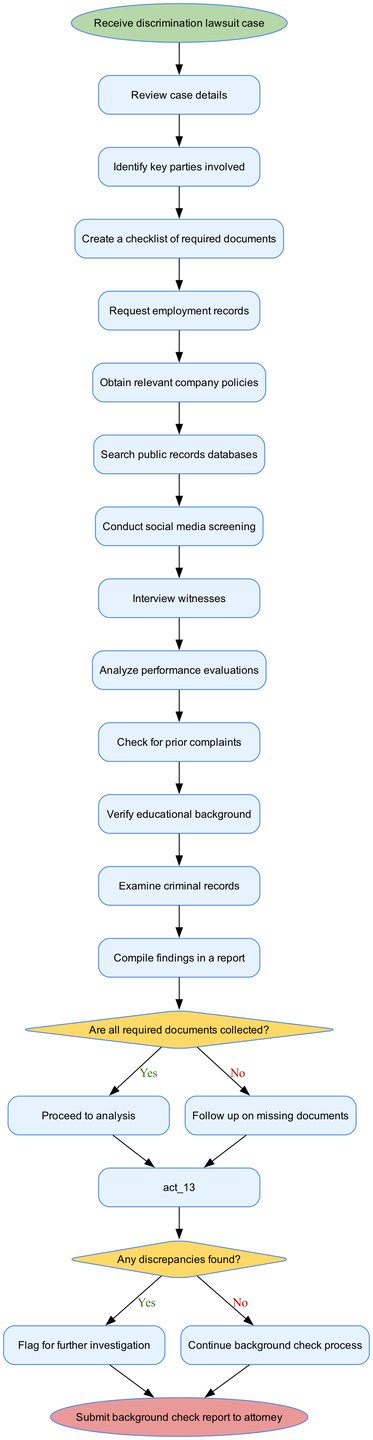What is the starting point of the diagram? The starting point is clearly labeled as "Receive discrimination lawsuit case," which is indicated by the ellipse shape at the top of the diagram.
Answer: Receive discrimination lawsuit case How many activities are listed in the diagram? By counting all the activities provided in the diagram, there are a total of 12 activities that contribute to the background check process.
Answer: 12 What is the decision point regarding document collection? The decision point about document collection is "Are all required documents collected?" which is represented by a diamond shape connected to the flow of the diagram.
Answer: Are all required documents collected? If the answer to the document collection decision is "No," what is the next step? If there are missing documents, the diagram indicates that the next step is to "Follow up on missing documents," which is shown on the diagram's flow as the outcome of the "No" path.
Answer: Follow up on missing documents What happens after finding discrepancies? Upon finding discrepancies, the diagram shows that the appropriate action is to "Flag for further investigation." This occurs when the decision node regarding discrepancies leads to the "Yes" branch.
Answer: Flag for further investigation How does one proceed after compiling findings? After compiling the findings in a report, the flow of the diagram indicates that the process concludes with "Submit background check report to attorney," emphasizing the final outcome of the activities completed.
Answer: Submit background check report to attorney Which activity occurs right before the decision on discrepancies? The last activity leading to the decision node about discrepancies is "Analyze performance evaluations," establishing the direct connection in the sequence of tasks.
Answer: Analyze performance evaluations What is the color of the start node? The start node is represented with a distinct color, specifically a light green shade, which is used in the diagram to visually differentiate it from other nodes.
Answer: Light green 